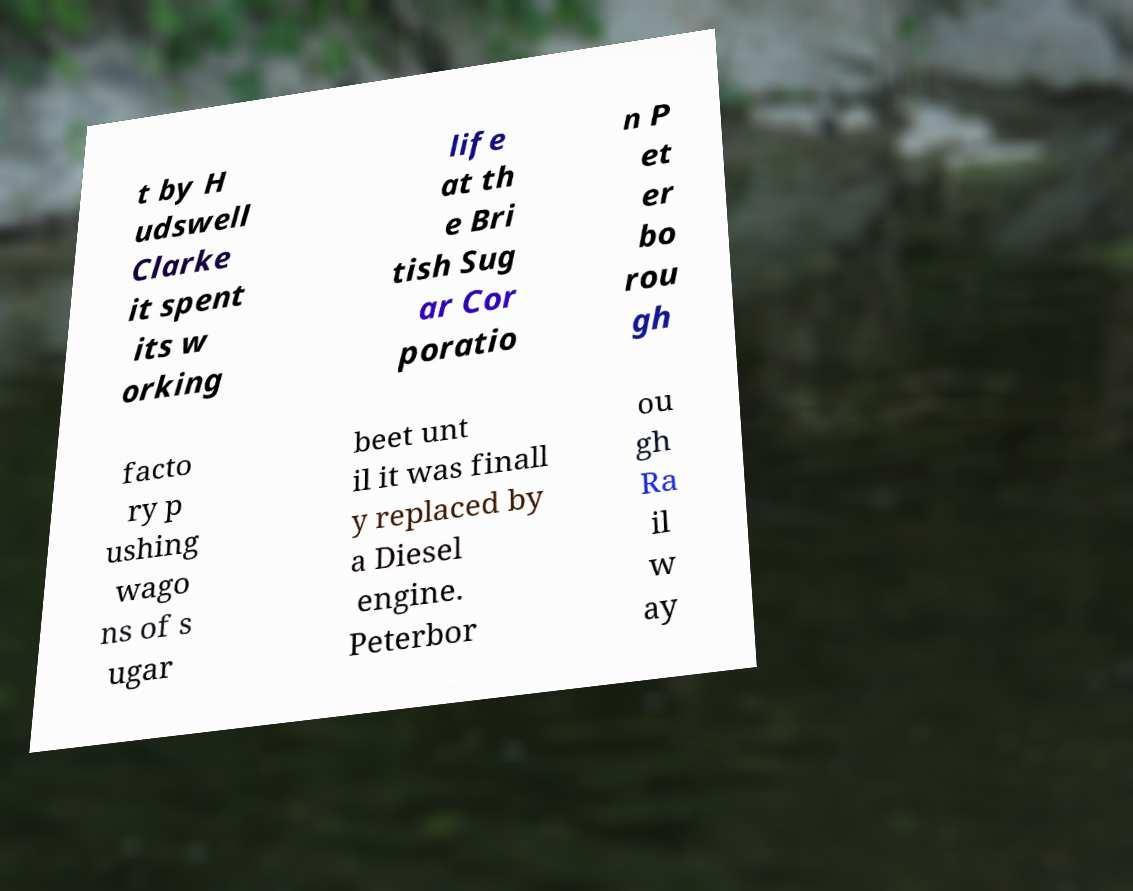Please identify and transcribe the text found in this image. t by H udswell Clarke it spent its w orking life at th e Bri tish Sug ar Cor poratio n P et er bo rou gh facto ry p ushing wago ns of s ugar beet unt il it was finall y replaced by a Diesel engine. Peterbor ou gh Ra il w ay 